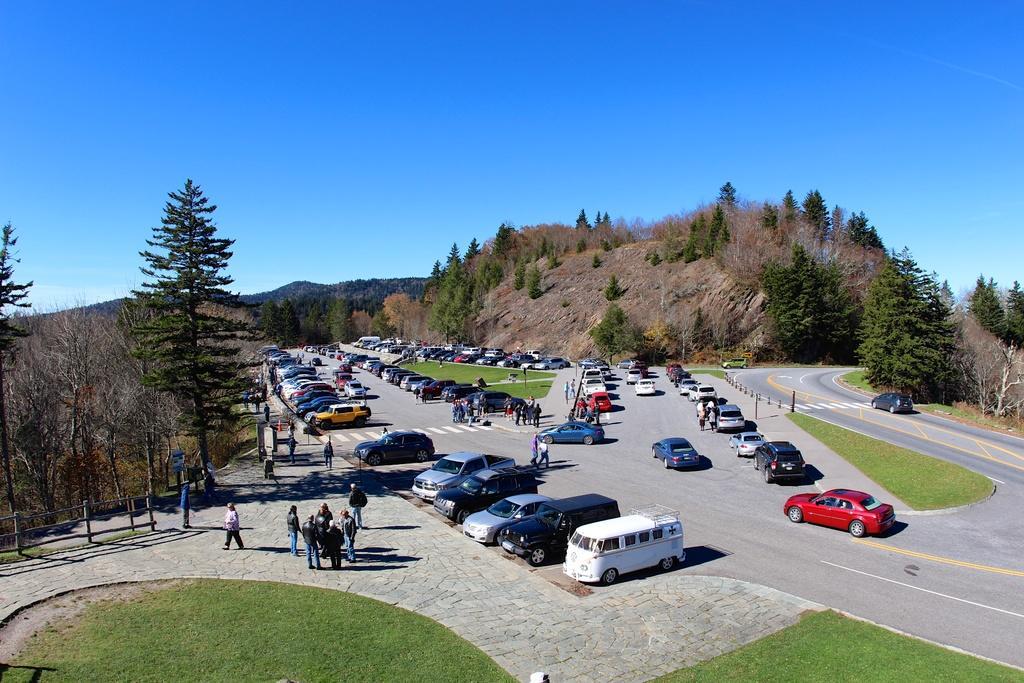Can you describe this image briefly? In this image there are vehicles on a road and there are people standing, in the background there are trees, mountains and the sky. 